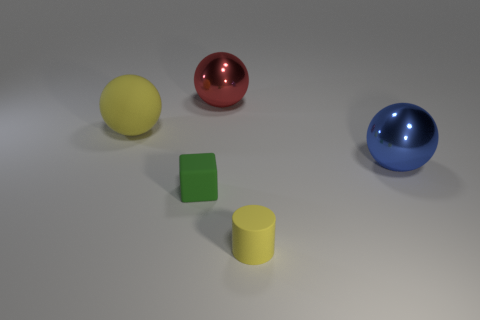Is the cylinder the same color as the matte sphere?
Ensure brevity in your answer.  Yes. How big is the thing that is behind the large sphere that is left of the block?
Provide a short and direct response. Large. Does the metallic object that is to the left of the rubber cylinder have the same size as the small matte cylinder?
Keep it short and to the point. No. Are there more objects in front of the blue metal thing than yellow cylinders behind the cylinder?
Provide a succinct answer. Yes. There is a thing that is right of the red metal ball and left of the blue metallic thing; what shape is it?
Your answer should be very brief. Cylinder. What is the shape of the yellow rubber object in front of the green block?
Your response must be concise. Cylinder. What is the size of the yellow matte thing to the left of the small object on the right side of the large metal ball that is on the left side of the tiny matte cylinder?
Make the answer very short. Large. Does the big red metal object have the same shape as the green object?
Keep it short and to the point. No. How big is the sphere that is in front of the large red shiny sphere and on the left side of the small yellow matte cylinder?
Ensure brevity in your answer.  Large. What material is the big yellow object that is the same shape as the red metal object?
Make the answer very short. Rubber. 